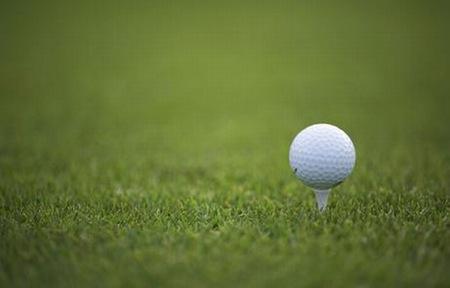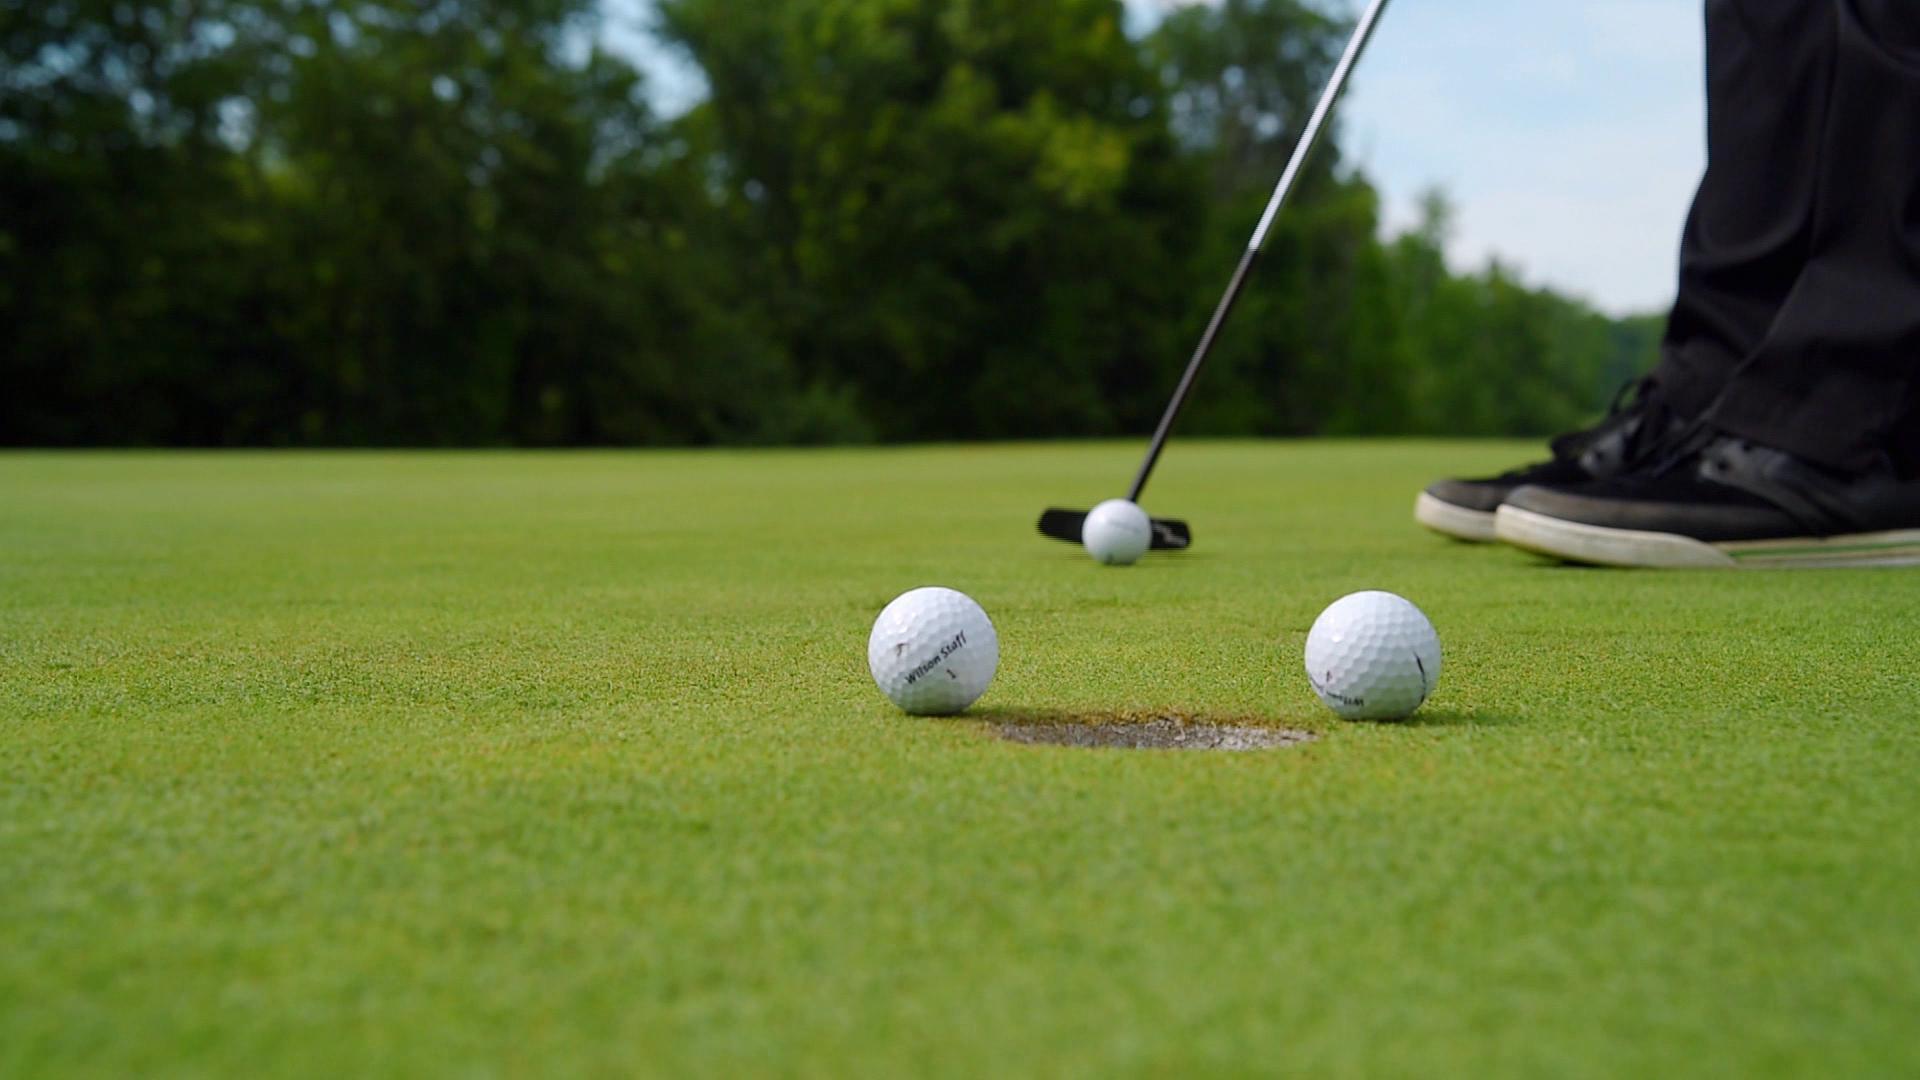The first image is the image on the left, the second image is the image on the right. Evaluate the accuracy of this statement regarding the images: "There are two balls near the hole in one of the images.". Is it true? Answer yes or no. Yes. The first image is the image on the left, the second image is the image on the right. Considering the images on both sides, is "At least one image includes a ball on a golf tee." valid? Answer yes or no. Yes. 